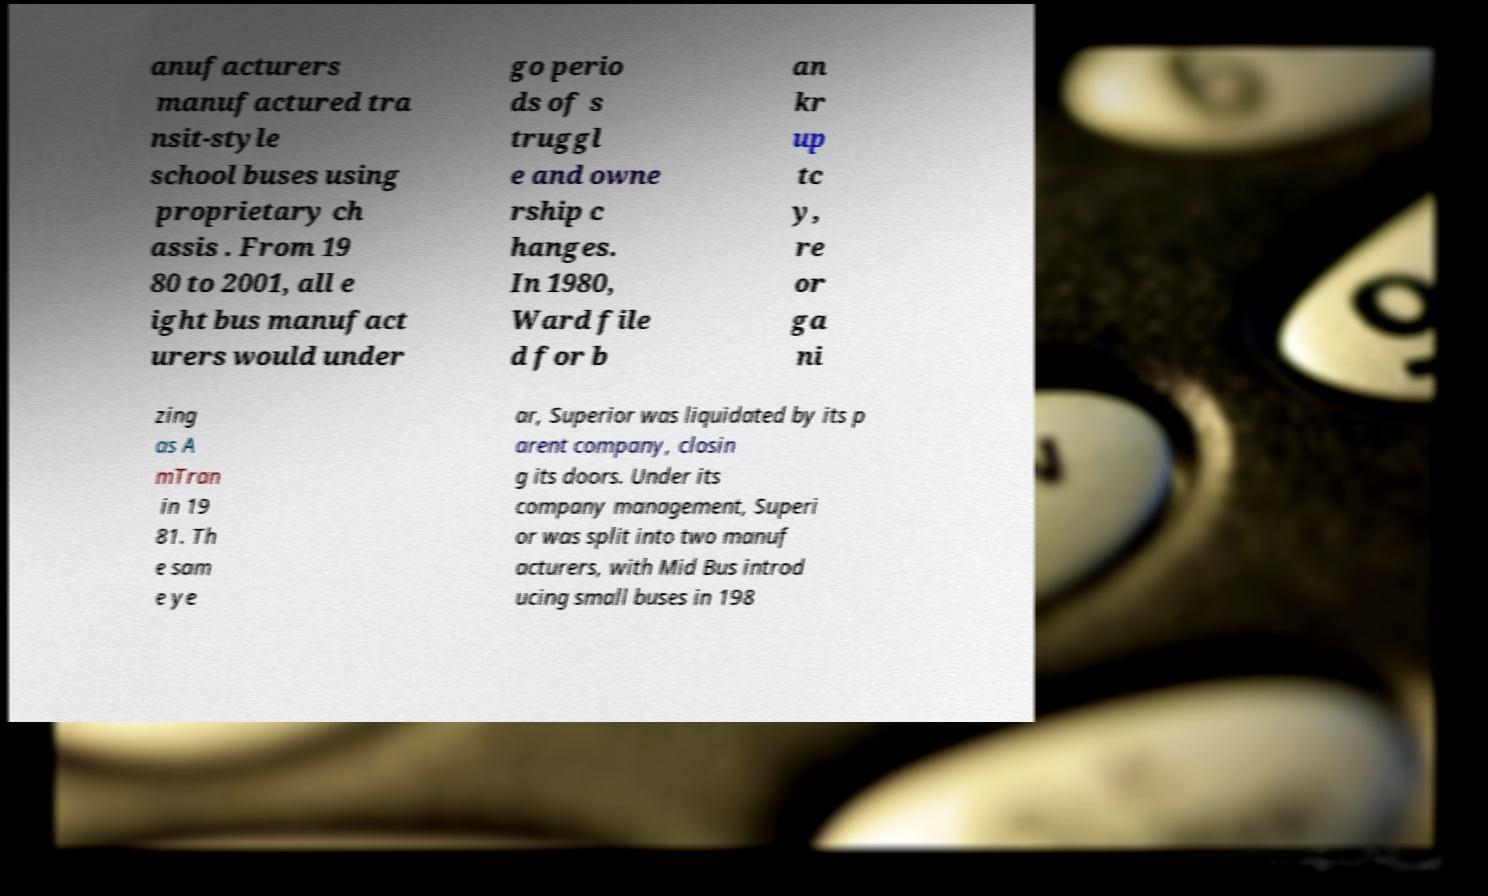Please read and relay the text visible in this image. What does it say? anufacturers manufactured tra nsit-style school buses using proprietary ch assis . From 19 80 to 2001, all e ight bus manufact urers would under go perio ds of s truggl e and owne rship c hanges. In 1980, Ward file d for b an kr up tc y, re or ga ni zing as A mTran in 19 81. Th e sam e ye ar, Superior was liquidated by its p arent company, closin g its doors. Under its company management, Superi or was split into two manuf acturers, with Mid Bus introd ucing small buses in 198 